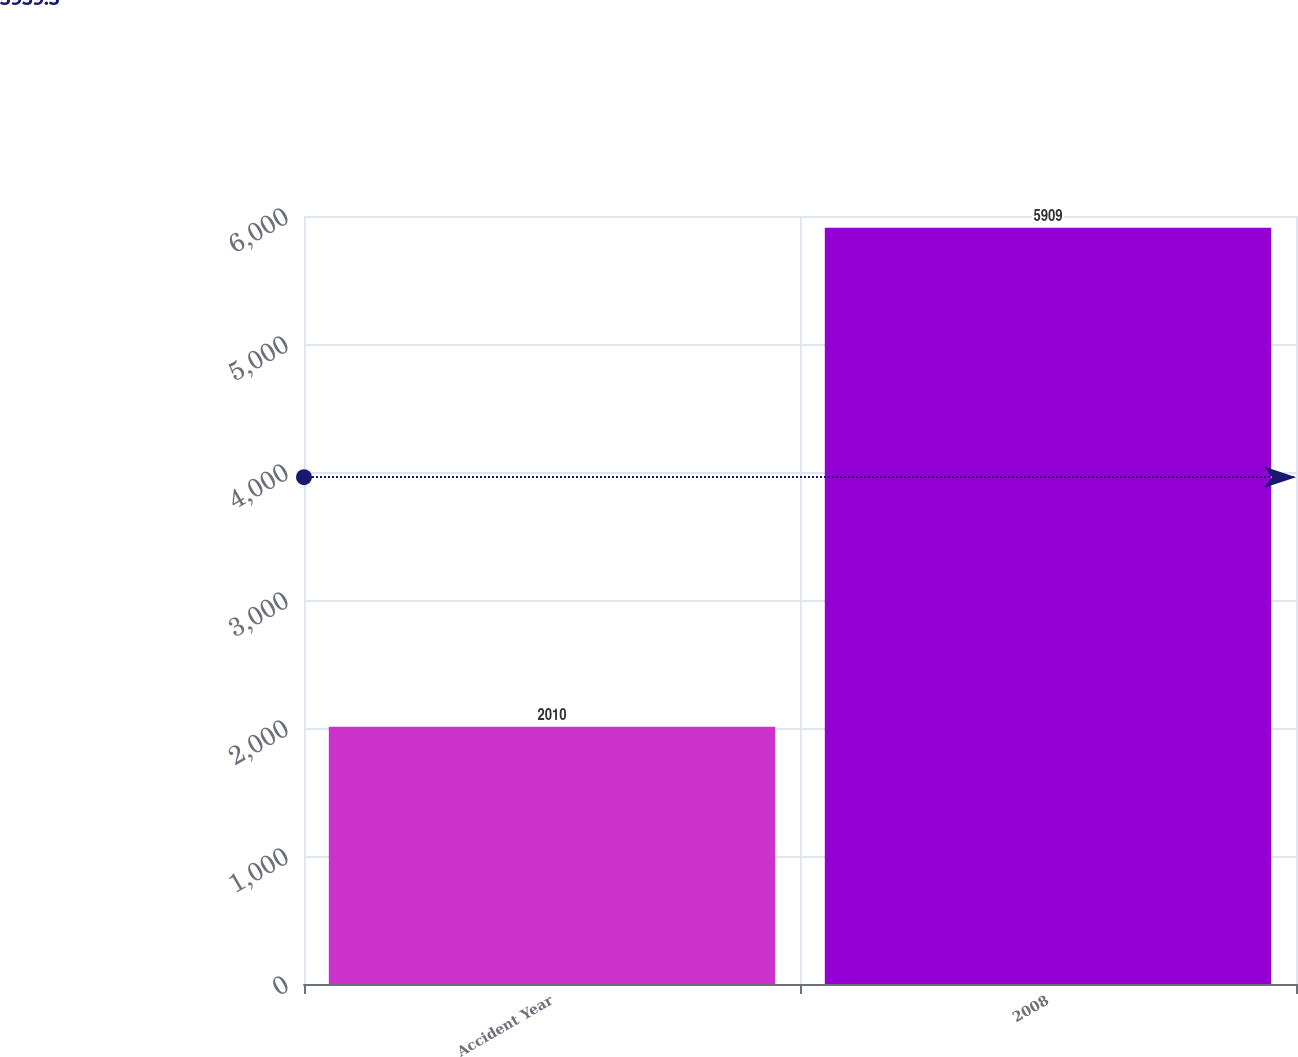<chart> <loc_0><loc_0><loc_500><loc_500><bar_chart><fcel>Accident Year<fcel>2008<nl><fcel>2010<fcel>5909<nl></chart> 